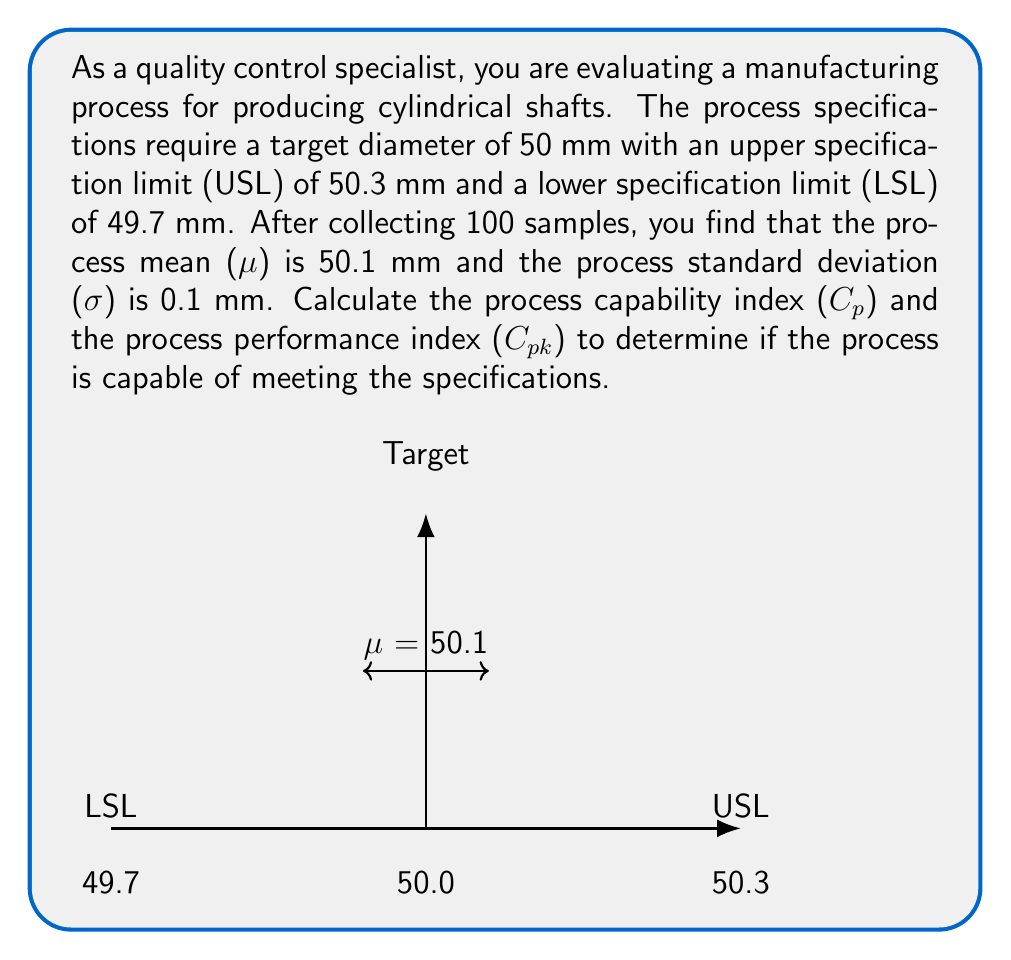Can you answer this question? To solve this problem, we'll follow these steps:

1) Calculate the process capability index (Cp):
   
   $$Cp = \frac{USL - LSL}{6σ}$$

   Where:
   USL = Upper Specification Limit = 50.3 mm
   LSL = Lower Specification Limit = 49.7 mm
   σ = Process Standard Deviation = 0.1 mm

   $$Cp = \frac{50.3 - 49.7}{6 * 0.1} = \frac{0.6}{0.6} = 1$$

2) Calculate the process performance index (Cpk):
   
   $$Cpk = min(\frac{USL - μ}{3σ}, \frac{μ - LSL}{3σ})$$

   Where:
   μ = Process Mean = 50.1 mm

   Upper Cpk:
   $$\frac{USL - μ}{3σ} = \frac{50.3 - 50.1}{3 * 0.1} = \frac{0.2}{0.3} = 0.67$$

   Lower Cpk:
   $$\frac{μ - LSL}{3σ} = \frac{50.1 - 49.7}{3 * 0.1} = \frac{0.4}{0.3} = 1.33$$

   $$Cpk = min(0.67, 1.33) = 0.67$$

3) Interpret the results:
   - Cp = 1 indicates that the process spread exactly matches the specification spread.
   - Cpk = 0.67 < 1 indicates that the process is not centered between the specification limits and is not capable of consistently meeting specifications.
Answer: Cp = 1, Cpk = 0.67 